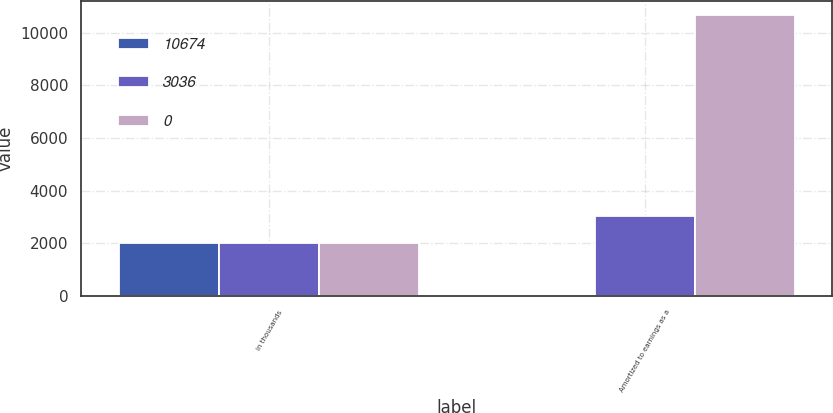Convert chart to OTSL. <chart><loc_0><loc_0><loc_500><loc_500><stacked_bar_chart><ecel><fcel>in thousands<fcel>Amortized to earnings as a<nl><fcel>10674<fcel>2016<fcel>0<nl><fcel>3036<fcel>2015<fcel>3036<nl><fcel>0<fcel>2014<fcel>10674<nl></chart> 